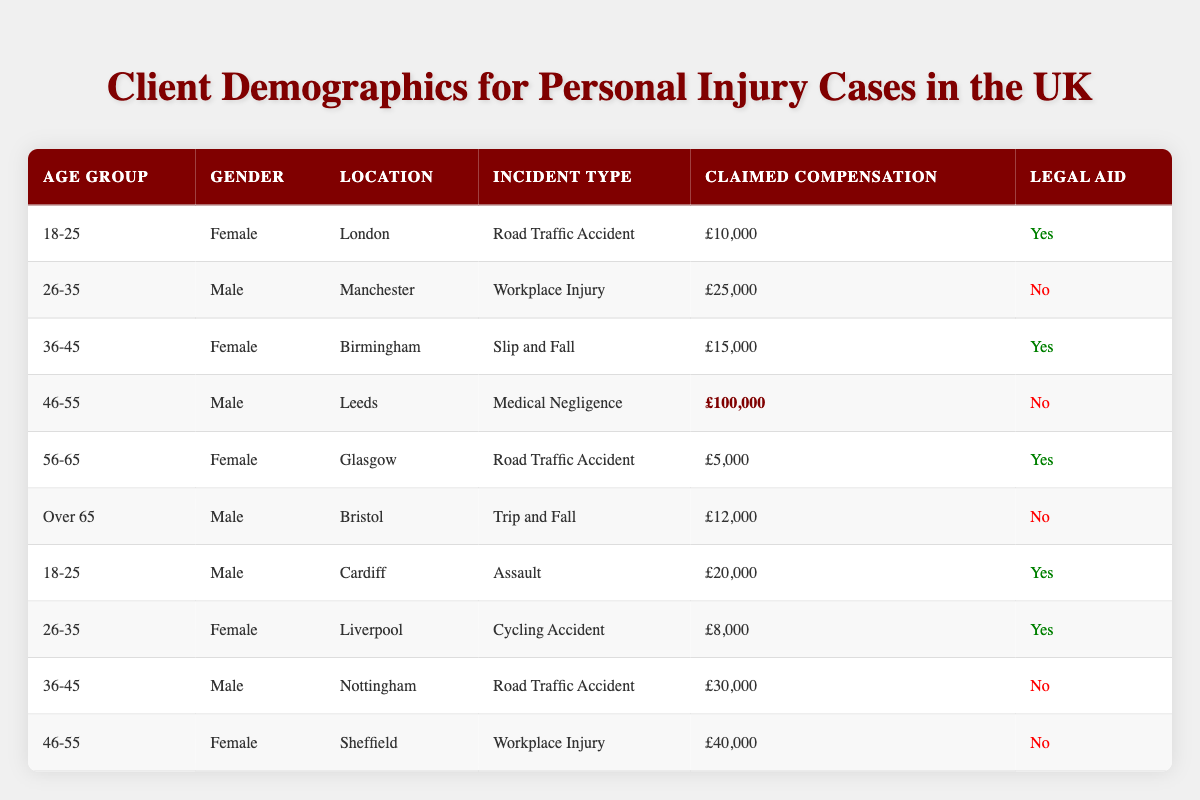What is the highest claimed compensation among the cases? By examining the "Claimed Compensation" column, the entries are £10,000, £25,000, £15,000, £100,000, £5,000, £12,000, £20,000, £8,000, £30,000, and £40,000. The highest value is £100,000 for the "Medical Negligence" incident in Leeds.
Answer: £100,000 How many clients in the age group "26-35" received legal aid? Looking at the "26-35" age group, the entries are one male client from Manchester who did not receive legal aid and one female client from Liverpool who did receive legal aid. Thus, there is one client who received legal aid.
Answer: 1 What type of incident did the male client from Cardiff experience? In the row corresponding to the male client from Cardiff in the "18-25" age group, the incident type listed is "Assault."
Answer: Assault How many total clients claimed compensation of over £20,000? The clients claiming over £20,000 are from Manchester (£25,000), Leeds (£100,000), Nottingham (£30,000), and Sheffield (£40,000). This gives a total of four clients with claims over £20,000.
Answer: 4 What is the average claimed compensation for clients who received legal aid? The clients with legal aid claimed £10,000, £15,000, £5,000, £20,000, and £8,000. Summing these amounts gives £58,000. There are five clients, so the average is £58,000 / 5 = £11,600.
Answer: £11,600 Which gender has more clients in the "Over 65" age group? In the "Over 65" age group, there is one male client from Bristol who experienced a "Trip and Fall." There are no female clients in this age group according to the data.
Answer: Male Is there any client who claimed compensation less than £10,000? By reviewing the "Claimed Compensation" column, £5,000 is the only value less than £10,000, attributed to the female client in Glasgow for a "Road Traffic Accident." Therefore, there is a client who claimed less than £10,000.
Answer: Yes What is the total claimed compensation for clients located in London? The only client located in London is the female client aged 18-25 who claimed £10,000. Therefore, the total claimed compensation for clients in London is simply £10,000.
Answer: £10,000 How many male clients had incidents related to "Road Traffic Accidents"? There are two male clients with "Road Traffic Accident" incidents – one aged 36-45 in Nottingham claiming £30,000 and one aged 18-25 in London claiming £10,000. Therefore, there are two male clients.
Answer: 2 Do clients in the age group "46-55" all have legal aid? Looking at the clients aged 46-55, we find one male client from Leeds and one female client from Sheffield, neither of whom received legal aid. Hence, not all clients in this age group have legal aid.
Answer: No Which location has the highest claimed compensation among the clients aged 18-25? For clients aged 18-25, we have one female client from London claiming £10,000 and one male client from Cardiff claiming £20,000. The male client from Cardiff has the highest claim of £20,000.
Answer: Cardiff 